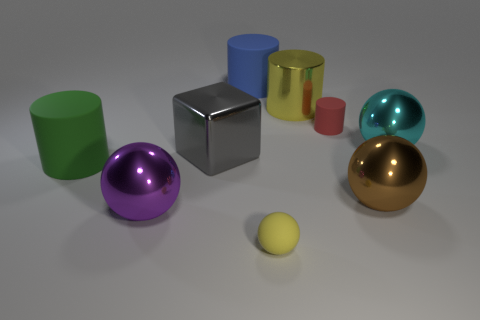Subtract all large green cylinders. How many cylinders are left? 3 Subtract all yellow balls. How many balls are left? 3 Subtract 1 cubes. How many cubes are left? 0 Subtract 0 blue balls. How many objects are left? 9 Subtract all cylinders. How many objects are left? 5 Subtract all cyan cylinders. Subtract all green balls. How many cylinders are left? 4 Subtract all green blocks. How many red balls are left? 0 Subtract all cyan metal balls. Subtract all big cyan things. How many objects are left? 7 Add 6 big purple things. How many big purple things are left? 7 Add 4 shiny things. How many shiny things exist? 9 